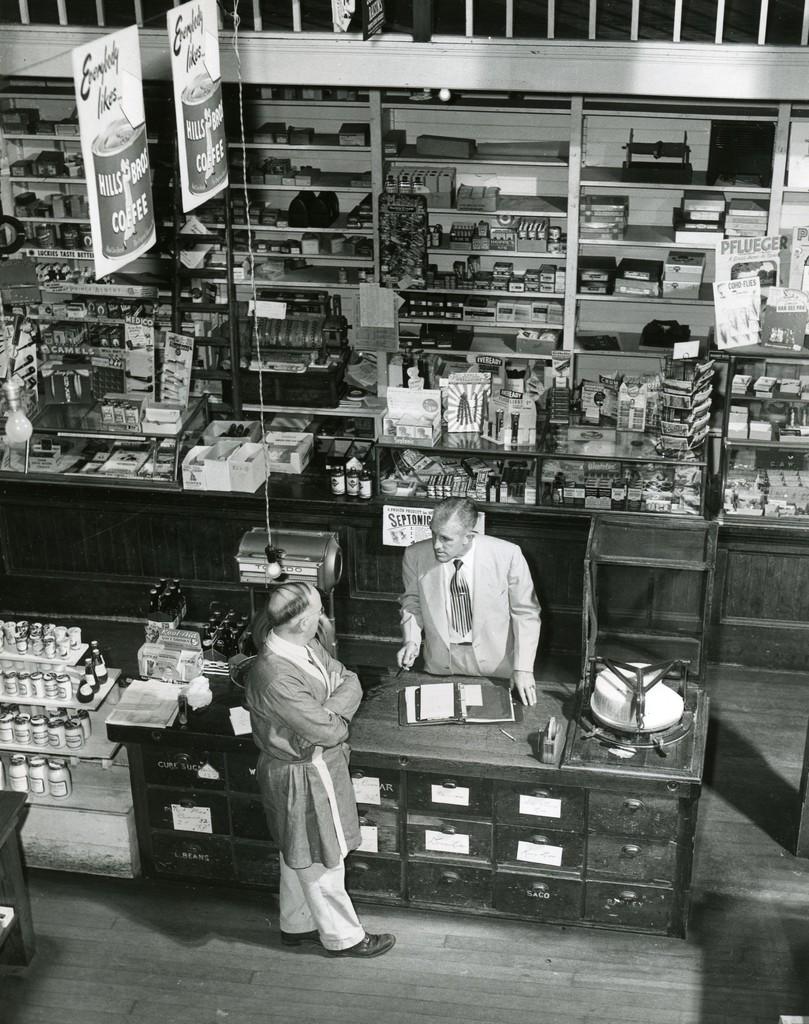What's the sign behind th ecounter person?
Your response must be concise. Septonic. What type of drink does everybody like, according to the banners?
Offer a very short reply. Hills bros coffee. 